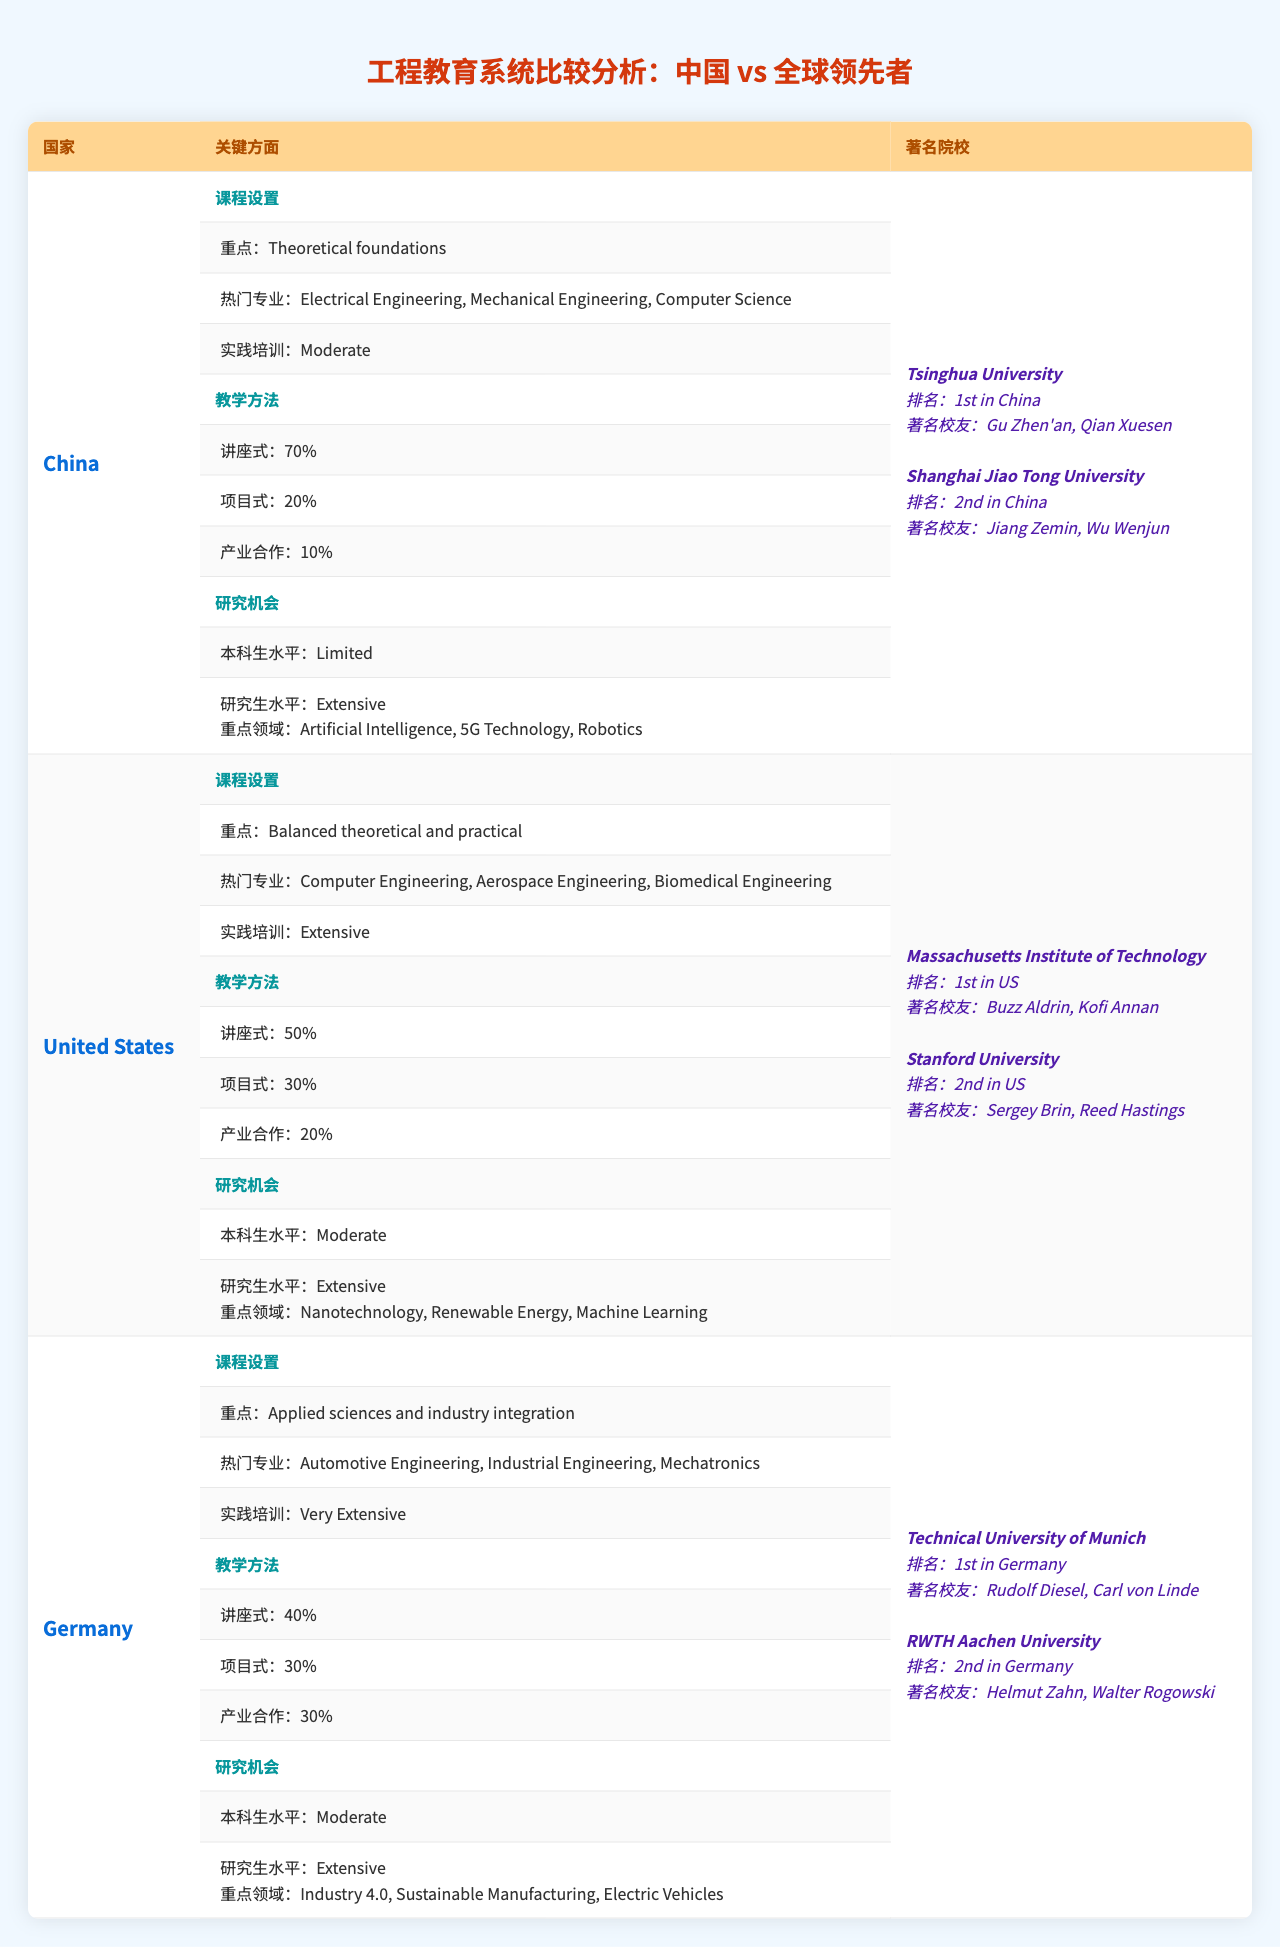What are the popular majors in China for engineering education? Referring to the table, the popular majors listed under China's curriculum are Electrical Engineering, Mechanical Engineering, and Computer Science.
Answer: Electrical Engineering, Mechanical Engineering, Computer Science Which country has the highest percentage of project-based teaching methods? From the table, Germany has 30% project-based teaching methods, which is higher than China (20%) and the United States (30%). Both Germany and the United States tie for the highest percentage.
Answer: Germany and the United States Is practical training more extensive in Germany compared to the United States? By checking the practical training values, Germany has "Very Extensive" while the United States is "Extensive," indicating that Germany offers more practical training.
Answer: Yes What is the focus area of research opportunities for undergraduates in China? The table notes that undergraduate research opportunities in China are "Limited," which directly answers the question about the focus area for undergraduates.
Answer: Limited Which country has the largest focus on industry collaboration in teaching methods? Germany has an equal distribution of teaching methods with 30% industry collaboration, compared to China (10%) and the United States (20%). Thus, Germany has the largest focus on industry collaboration.
Answer: Germany What is the average practical training level across these three countries? The practical training levels are Moderate for China, Extensive for the United States, and Very Extensive for Germany. In terms of average, we qualitatively rank them as Low (Moderate), Medium (Extensive), and High (Very Extensive). Thus, the average level ranks around "Medium."
Answer: Medium Which country lists "Artificial Intelligence" as a focus area for research opportunities? Upon reviewing the table, "Artificial Intelligence" is listed as a focus area for research opportunities at the graduate level in China.
Answer: China Are there any countries with a notable institution ranking higher than 1st listed in the table? The table presents Tsinghua University and the Massachusetts Institute of Technology as the top institutions in China and the USA, respectively; there are no institutions ranked higher than 1st.
Answer: No What is the unique focus area mentioned for graduate-level research in the United States? Within the table, the focus areas for graduate-level research in the United States include Nanotechnology, Renewable Energy, and Machine Learning, which are unique to this country.
Answer: Nanotechnology, Renewable Energy, Machine Learning Does Germany have a theoretical focus in its engineering curriculum? The curriculum focus in Germany is on applied sciences and industry integration, which does not align with a primary theoretical focus. Thus, the statement is false for Germany.
Answer: No 